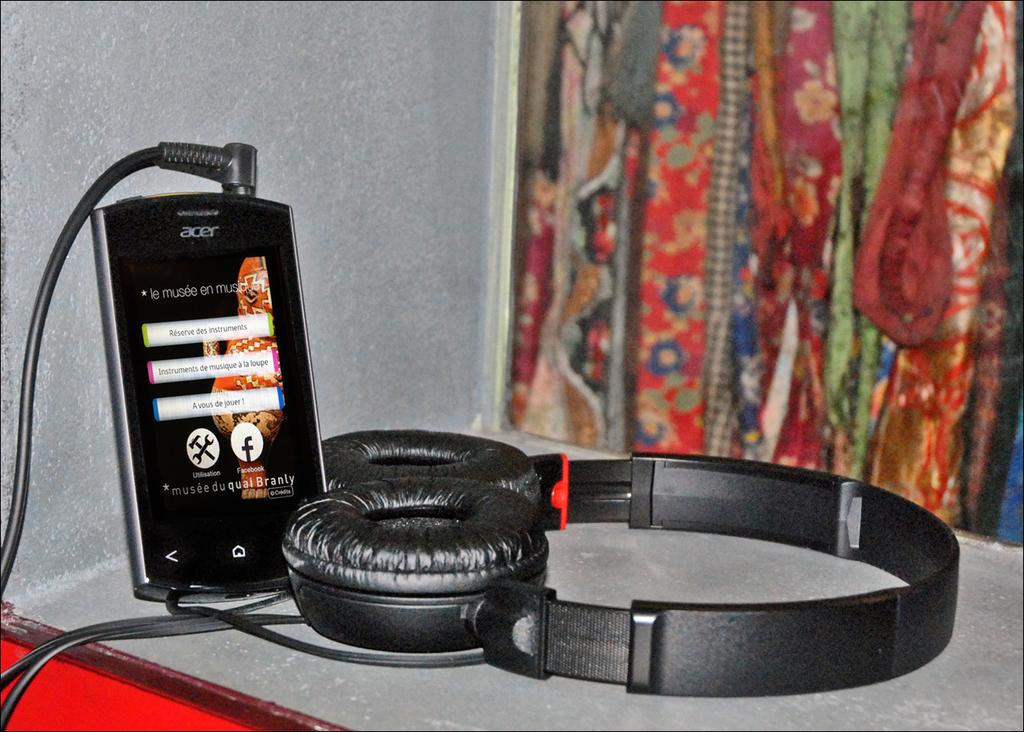Provide a one-sentence caption for the provided image. Acer phone sits on a table hooked up to earphone. 